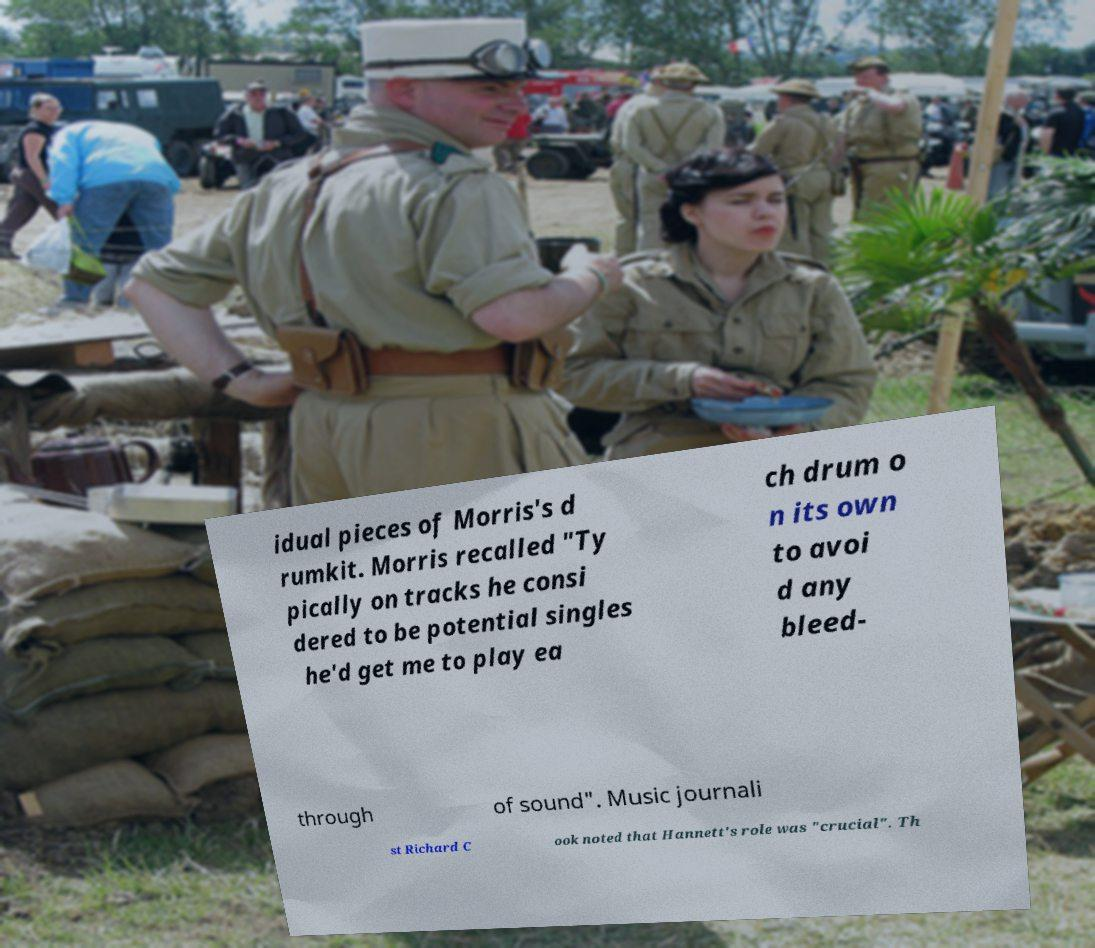There's text embedded in this image that I need extracted. Can you transcribe it verbatim? idual pieces of Morris's d rumkit. Morris recalled "Ty pically on tracks he consi dered to be potential singles he'd get me to play ea ch drum o n its own to avoi d any bleed- through of sound". Music journali st Richard C ook noted that Hannett's role was "crucial". Th 